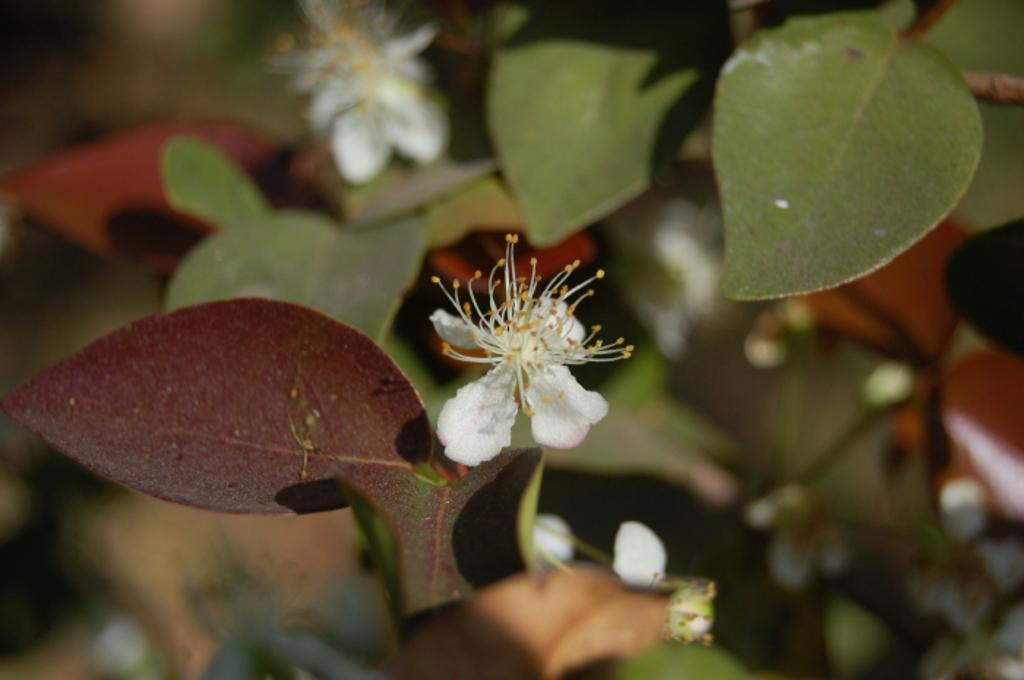What type of plant life is visible in the image? There are flowers and leaves in the image. What can be inferred about the focus of the image? The background of the image is blurred, suggesting that the flowers and leaves are the main focus. Where is the scarecrow standing in the image? There is no scarecrow present in the image. What type of clover can be seen growing among the flowers in the image? There is no clover visible in the image; only flowers and leaves are present. 